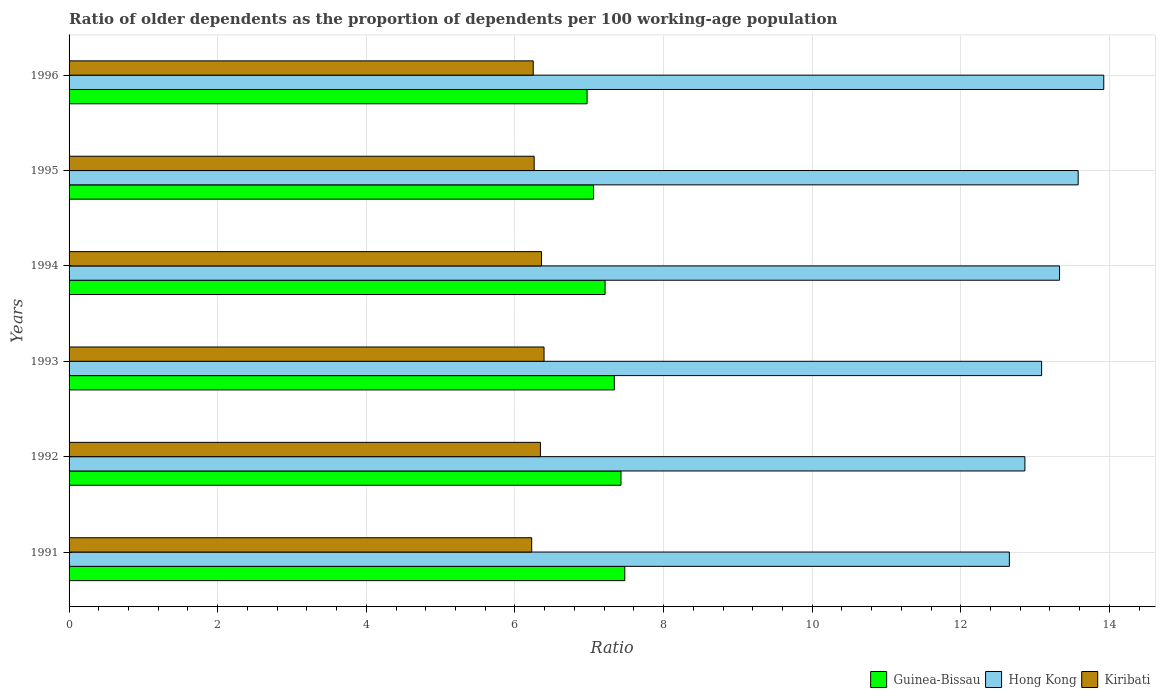How many different coloured bars are there?
Provide a succinct answer. 3. Are the number of bars per tick equal to the number of legend labels?
Keep it short and to the point. Yes. How many bars are there on the 5th tick from the bottom?
Give a very brief answer. 3. In how many cases, is the number of bars for a given year not equal to the number of legend labels?
Your answer should be compact. 0. What is the age dependency ratio(old) in Hong Kong in 1991?
Your response must be concise. 12.65. Across all years, what is the maximum age dependency ratio(old) in Guinea-Bissau?
Offer a very short reply. 7.48. Across all years, what is the minimum age dependency ratio(old) in Guinea-Bissau?
Give a very brief answer. 6.97. In which year was the age dependency ratio(old) in Kiribati maximum?
Your answer should be compact. 1993. What is the total age dependency ratio(old) in Hong Kong in the graph?
Provide a short and direct response. 79.44. What is the difference between the age dependency ratio(old) in Guinea-Bissau in 1994 and that in 1995?
Keep it short and to the point. 0.15. What is the difference between the age dependency ratio(old) in Guinea-Bissau in 1994 and the age dependency ratio(old) in Hong Kong in 1991?
Your answer should be very brief. -5.44. What is the average age dependency ratio(old) in Guinea-Bissau per year?
Provide a succinct answer. 7.25. In the year 1996, what is the difference between the age dependency ratio(old) in Kiribati and age dependency ratio(old) in Hong Kong?
Your answer should be compact. -7.68. What is the ratio of the age dependency ratio(old) in Hong Kong in 1993 to that in 1995?
Your answer should be very brief. 0.96. Is the difference between the age dependency ratio(old) in Kiribati in 1991 and 1994 greater than the difference between the age dependency ratio(old) in Hong Kong in 1991 and 1994?
Make the answer very short. Yes. What is the difference between the highest and the second highest age dependency ratio(old) in Guinea-Bissau?
Your answer should be compact. 0.05. What is the difference between the highest and the lowest age dependency ratio(old) in Hong Kong?
Give a very brief answer. 1.27. In how many years, is the age dependency ratio(old) in Guinea-Bissau greater than the average age dependency ratio(old) in Guinea-Bissau taken over all years?
Provide a succinct answer. 3. What does the 3rd bar from the top in 1996 represents?
Offer a very short reply. Guinea-Bissau. What does the 3rd bar from the bottom in 1993 represents?
Provide a short and direct response. Kiribati. How many bars are there?
Give a very brief answer. 18. Are all the bars in the graph horizontal?
Offer a very short reply. Yes. How many years are there in the graph?
Your answer should be very brief. 6. Are the values on the major ticks of X-axis written in scientific E-notation?
Your answer should be very brief. No. Does the graph contain grids?
Keep it short and to the point. Yes. Where does the legend appear in the graph?
Offer a terse response. Bottom right. How many legend labels are there?
Offer a terse response. 3. What is the title of the graph?
Make the answer very short. Ratio of older dependents as the proportion of dependents per 100 working-age population. Does "Latin America(developing only)" appear as one of the legend labels in the graph?
Your response must be concise. No. What is the label or title of the X-axis?
Your response must be concise. Ratio. What is the Ratio of Guinea-Bissau in 1991?
Make the answer very short. 7.48. What is the Ratio in Hong Kong in 1991?
Ensure brevity in your answer.  12.65. What is the Ratio in Kiribati in 1991?
Provide a short and direct response. 6.23. What is the Ratio in Guinea-Bissau in 1992?
Your answer should be very brief. 7.43. What is the Ratio in Hong Kong in 1992?
Make the answer very short. 12.86. What is the Ratio in Kiribati in 1992?
Your answer should be compact. 6.34. What is the Ratio of Guinea-Bissau in 1993?
Offer a very short reply. 7.34. What is the Ratio in Hong Kong in 1993?
Give a very brief answer. 13.09. What is the Ratio of Kiribati in 1993?
Your answer should be very brief. 6.39. What is the Ratio of Guinea-Bissau in 1994?
Give a very brief answer. 7.21. What is the Ratio in Hong Kong in 1994?
Make the answer very short. 13.33. What is the Ratio of Kiribati in 1994?
Your answer should be compact. 6.36. What is the Ratio in Guinea-Bissau in 1995?
Give a very brief answer. 7.06. What is the Ratio of Hong Kong in 1995?
Offer a very short reply. 13.58. What is the Ratio in Kiribati in 1995?
Your answer should be compact. 6.26. What is the Ratio of Guinea-Bissau in 1996?
Your answer should be compact. 6.97. What is the Ratio in Hong Kong in 1996?
Offer a very short reply. 13.92. What is the Ratio of Kiribati in 1996?
Your answer should be very brief. 6.25. Across all years, what is the maximum Ratio of Guinea-Bissau?
Your answer should be compact. 7.48. Across all years, what is the maximum Ratio in Hong Kong?
Your answer should be very brief. 13.92. Across all years, what is the maximum Ratio in Kiribati?
Your response must be concise. 6.39. Across all years, what is the minimum Ratio in Guinea-Bissau?
Your answer should be very brief. 6.97. Across all years, what is the minimum Ratio in Hong Kong?
Your response must be concise. 12.65. Across all years, what is the minimum Ratio of Kiribati?
Offer a terse response. 6.23. What is the total Ratio of Guinea-Bissau in the graph?
Provide a succinct answer. 43.49. What is the total Ratio of Hong Kong in the graph?
Give a very brief answer. 79.44. What is the total Ratio in Kiribati in the graph?
Your response must be concise. 37.82. What is the difference between the Ratio of Guinea-Bissau in 1991 and that in 1992?
Ensure brevity in your answer.  0.05. What is the difference between the Ratio of Hong Kong in 1991 and that in 1992?
Your response must be concise. -0.21. What is the difference between the Ratio in Kiribati in 1991 and that in 1992?
Your response must be concise. -0.12. What is the difference between the Ratio of Guinea-Bissau in 1991 and that in 1993?
Make the answer very short. 0.14. What is the difference between the Ratio of Hong Kong in 1991 and that in 1993?
Make the answer very short. -0.43. What is the difference between the Ratio in Kiribati in 1991 and that in 1993?
Your answer should be very brief. -0.17. What is the difference between the Ratio of Guinea-Bissau in 1991 and that in 1994?
Offer a very short reply. 0.27. What is the difference between the Ratio in Hong Kong in 1991 and that in 1994?
Ensure brevity in your answer.  -0.68. What is the difference between the Ratio in Kiribati in 1991 and that in 1994?
Make the answer very short. -0.13. What is the difference between the Ratio of Guinea-Bissau in 1991 and that in 1995?
Your response must be concise. 0.42. What is the difference between the Ratio of Hong Kong in 1991 and that in 1995?
Offer a very short reply. -0.93. What is the difference between the Ratio of Kiribati in 1991 and that in 1995?
Offer a very short reply. -0.03. What is the difference between the Ratio in Guinea-Bissau in 1991 and that in 1996?
Offer a very short reply. 0.51. What is the difference between the Ratio of Hong Kong in 1991 and that in 1996?
Ensure brevity in your answer.  -1.27. What is the difference between the Ratio in Kiribati in 1991 and that in 1996?
Keep it short and to the point. -0.02. What is the difference between the Ratio of Guinea-Bissau in 1992 and that in 1993?
Provide a short and direct response. 0.09. What is the difference between the Ratio in Hong Kong in 1992 and that in 1993?
Ensure brevity in your answer.  -0.23. What is the difference between the Ratio in Kiribati in 1992 and that in 1993?
Your answer should be compact. -0.05. What is the difference between the Ratio of Guinea-Bissau in 1992 and that in 1994?
Provide a short and direct response. 0.21. What is the difference between the Ratio of Hong Kong in 1992 and that in 1994?
Your response must be concise. -0.47. What is the difference between the Ratio of Kiribati in 1992 and that in 1994?
Your response must be concise. -0.01. What is the difference between the Ratio of Guinea-Bissau in 1992 and that in 1995?
Make the answer very short. 0.37. What is the difference between the Ratio in Hong Kong in 1992 and that in 1995?
Make the answer very short. -0.72. What is the difference between the Ratio in Kiribati in 1992 and that in 1995?
Make the answer very short. 0.08. What is the difference between the Ratio in Guinea-Bissau in 1992 and that in 1996?
Your response must be concise. 0.46. What is the difference between the Ratio in Hong Kong in 1992 and that in 1996?
Your answer should be compact. -1.06. What is the difference between the Ratio in Kiribati in 1992 and that in 1996?
Offer a very short reply. 0.1. What is the difference between the Ratio of Guinea-Bissau in 1993 and that in 1994?
Your response must be concise. 0.12. What is the difference between the Ratio in Hong Kong in 1993 and that in 1994?
Your answer should be very brief. -0.24. What is the difference between the Ratio in Kiribati in 1993 and that in 1994?
Keep it short and to the point. 0.03. What is the difference between the Ratio in Guinea-Bissau in 1993 and that in 1995?
Your answer should be very brief. 0.28. What is the difference between the Ratio in Hong Kong in 1993 and that in 1995?
Your response must be concise. -0.49. What is the difference between the Ratio of Kiribati in 1993 and that in 1995?
Provide a short and direct response. 0.13. What is the difference between the Ratio of Guinea-Bissau in 1993 and that in 1996?
Provide a short and direct response. 0.37. What is the difference between the Ratio in Hong Kong in 1993 and that in 1996?
Your answer should be very brief. -0.84. What is the difference between the Ratio of Kiribati in 1993 and that in 1996?
Make the answer very short. 0.15. What is the difference between the Ratio in Guinea-Bissau in 1994 and that in 1995?
Provide a short and direct response. 0.15. What is the difference between the Ratio in Hong Kong in 1994 and that in 1995?
Your answer should be very brief. -0.25. What is the difference between the Ratio in Kiribati in 1994 and that in 1995?
Your answer should be very brief. 0.1. What is the difference between the Ratio in Guinea-Bissau in 1994 and that in 1996?
Your answer should be very brief. 0.24. What is the difference between the Ratio of Hong Kong in 1994 and that in 1996?
Keep it short and to the point. -0.59. What is the difference between the Ratio of Kiribati in 1994 and that in 1996?
Your answer should be very brief. 0.11. What is the difference between the Ratio in Guinea-Bissau in 1995 and that in 1996?
Ensure brevity in your answer.  0.09. What is the difference between the Ratio in Hong Kong in 1995 and that in 1996?
Your answer should be compact. -0.34. What is the difference between the Ratio in Kiribati in 1995 and that in 1996?
Your response must be concise. 0.01. What is the difference between the Ratio in Guinea-Bissau in 1991 and the Ratio in Hong Kong in 1992?
Your answer should be very brief. -5.38. What is the difference between the Ratio of Guinea-Bissau in 1991 and the Ratio of Kiribati in 1992?
Your answer should be very brief. 1.14. What is the difference between the Ratio in Hong Kong in 1991 and the Ratio in Kiribati in 1992?
Provide a succinct answer. 6.31. What is the difference between the Ratio in Guinea-Bissau in 1991 and the Ratio in Hong Kong in 1993?
Your response must be concise. -5.61. What is the difference between the Ratio in Guinea-Bissau in 1991 and the Ratio in Kiribati in 1993?
Your response must be concise. 1.09. What is the difference between the Ratio of Hong Kong in 1991 and the Ratio of Kiribati in 1993?
Make the answer very short. 6.26. What is the difference between the Ratio of Guinea-Bissau in 1991 and the Ratio of Hong Kong in 1994?
Offer a terse response. -5.85. What is the difference between the Ratio of Guinea-Bissau in 1991 and the Ratio of Kiribati in 1994?
Your answer should be very brief. 1.12. What is the difference between the Ratio in Hong Kong in 1991 and the Ratio in Kiribati in 1994?
Your answer should be very brief. 6.3. What is the difference between the Ratio in Guinea-Bissau in 1991 and the Ratio in Hong Kong in 1995?
Provide a short and direct response. -6.1. What is the difference between the Ratio in Guinea-Bissau in 1991 and the Ratio in Kiribati in 1995?
Your response must be concise. 1.22. What is the difference between the Ratio of Hong Kong in 1991 and the Ratio of Kiribati in 1995?
Keep it short and to the point. 6.39. What is the difference between the Ratio in Guinea-Bissau in 1991 and the Ratio in Hong Kong in 1996?
Your response must be concise. -6.45. What is the difference between the Ratio in Guinea-Bissau in 1991 and the Ratio in Kiribati in 1996?
Provide a short and direct response. 1.23. What is the difference between the Ratio of Hong Kong in 1991 and the Ratio of Kiribati in 1996?
Provide a short and direct response. 6.41. What is the difference between the Ratio in Guinea-Bissau in 1992 and the Ratio in Hong Kong in 1993?
Ensure brevity in your answer.  -5.66. What is the difference between the Ratio in Guinea-Bissau in 1992 and the Ratio in Kiribati in 1993?
Your answer should be very brief. 1.04. What is the difference between the Ratio in Hong Kong in 1992 and the Ratio in Kiribati in 1993?
Offer a very short reply. 6.47. What is the difference between the Ratio in Guinea-Bissau in 1992 and the Ratio in Hong Kong in 1994?
Provide a short and direct response. -5.9. What is the difference between the Ratio of Guinea-Bissau in 1992 and the Ratio of Kiribati in 1994?
Give a very brief answer. 1.07. What is the difference between the Ratio in Hong Kong in 1992 and the Ratio in Kiribati in 1994?
Give a very brief answer. 6.5. What is the difference between the Ratio in Guinea-Bissau in 1992 and the Ratio in Hong Kong in 1995?
Your answer should be compact. -6.15. What is the difference between the Ratio of Guinea-Bissau in 1992 and the Ratio of Kiribati in 1995?
Offer a very short reply. 1.17. What is the difference between the Ratio in Hong Kong in 1992 and the Ratio in Kiribati in 1995?
Provide a succinct answer. 6.6. What is the difference between the Ratio in Guinea-Bissau in 1992 and the Ratio in Hong Kong in 1996?
Provide a short and direct response. -6.5. What is the difference between the Ratio in Guinea-Bissau in 1992 and the Ratio in Kiribati in 1996?
Give a very brief answer. 1.18. What is the difference between the Ratio of Hong Kong in 1992 and the Ratio of Kiribati in 1996?
Your response must be concise. 6.62. What is the difference between the Ratio of Guinea-Bissau in 1993 and the Ratio of Hong Kong in 1994?
Your response must be concise. -5.99. What is the difference between the Ratio in Guinea-Bissau in 1993 and the Ratio in Kiribati in 1994?
Your answer should be compact. 0.98. What is the difference between the Ratio in Hong Kong in 1993 and the Ratio in Kiribati in 1994?
Provide a short and direct response. 6.73. What is the difference between the Ratio in Guinea-Bissau in 1993 and the Ratio in Hong Kong in 1995?
Offer a terse response. -6.24. What is the difference between the Ratio of Guinea-Bissau in 1993 and the Ratio of Kiribati in 1995?
Your response must be concise. 1.08. What is the difference between the Ratio in Hong Kong in 1993 and the Ratio in Kiribati in 1995?
Your answer should be very brief. 6.83. What is the difference between the Ratio of Guinea-Bissau in 1993 and the Ratio of Hong Kong in 1996?
Ensure brevity in your answer.  -6.59. What is the difference between the Ratio of Guinea-Bissau in 1993 and the Ratio of Kiribati in 1996?
Provide a succinct answer. 1.09. What is the difference between the Ratio of Hong Kong in 1993 and the Ratio of Kiribati in 1996?
Your response must be concise. 6.84. What is the difference between the Ratio in Guinea-Bissau in 1994 and the Ratio in Hong Kong in 1995?
Offer a terse response. -6.37. What is the difference between the Ratio of Guinea-Bissau in 1994 and the Ratio of Kiribati in 1995?
Keep it short and to the point. 0.95. What is the difference between the Ratio of Hong Kong in 1994 and the Ratio of Kiribati in 1995?
Your answer should be compact. 7.07. What is the difference between the Ratio in Guinea-Bissau in 1994 and the Ratio in Hong Kong in 1996?
Your response must be concise. -6.71. What is the difference between the Ratio in Guinea-Bissau in 1994 and the Ratio in Kiribati in 1996?
Offer a terse response. 0.97. What is the difference between the Ratio of Hong Kong in 1994 and the Ratio of Kiribati in 1996?
Make the answer very short. 7.08. What is the difference between the Ratio of Guinea-Bissau in 1995 and the Ratio of Hong Kong in 1996?
Offer a very short reply. -6.87. What is the difference between the Ratio in Guinea-Bissau in 1995 and the Ratio in Kiribati in 1996?
Keep it short and to the point. 0.81. What is the difference between the Ratio of Hong Kong in 1995 and the Ratio of Kiribati in 1996?
Provide a succinct answer. 7.33. What is the average Ratio in Guinea-Bissau per year?
Offer a terse response. 7.25. What is the average Ratio in Hong Kong per year?
Your answer should be very brief. 13.24. What is the average Ratio in Kiribati per year?
Make the answer very short. 6.3. In the year 1991, what is the difference between the Ratio in Guinea-Bissau and Ratio in Hong Kong?
Your response must be concise. -5.18. In the year 1991, what is the difference between the Ratio of Guinea-Bissau and Ratio of Kiribati?
Provide a short and direct response. 1.25. In the year 1991, what is the difference between the Ratio of Hong Kong and Ratio of Kiribati?
Provide a short and direct response. 6.43. In the year 1992, what is the difference between the Ratio of Guinea-Bissau and Ratio of Hong Kong?
Offer a very short reply. -5.43. In the year 1992, what is the difference between the Ratio in Guinea-Bissau and Ratio in Kiribati?
Provide a short and direct response. 1.08. In the year 1992, what is the difference between the Ratio in Hong Kong and Ratio in Kiribati?
Offer a very short reply. 6.52. In the year 1993, what is the difference between the Ratio of Guinea-Bissau and Ratio of Hong Kong?
Keep it short and to the point. -5.75. In the year 1993, what is the difference between the Ratio of Guinea-Bissau and Ratio of Kiribati?
Your answer should be very brief. 0.95. In the year 1993, what is the difference between the Ratio of Hong Kong and Ratio of Kiribati?
Ensure brevity in your answer.  6.7. In the year 1994, what is the difference between the Ratio in Guinea-Bissau and Ratio in Hong Kong?
Ensure brevity in your answer.  -6.12. In the year 1994, what is the difference between the Ratio of Guinea-Bissau and Ratio of Kiribati?
Provide a short and direct response. 0.86. In the year 1994, what is the difference between the Ratio in Hong Kong and Ratio in Kiribati?
Your answer should be very brief. 6.97. In the year 1995, what is the difference between the Ratio of Guinea-Bissau and Ratio of Hong Kong?
Your answer should be compact. -6.52. In the year 1995, what is the difference between the Ratio of Guinea-Bissau and Ratio of Kiribati?
Provide a succinct answer. 0.8. In the year 1995, what is the difference between the Ratio of Hong Kong and Ratio of Kiribati?
Offer a very short reply. 7.32. In the year 1996, what is the difference between the Ratio in Guinea-Bissau and Ratio in Hong Kong?
Provide a succinct answer. -6.95. In the year 1996, what is the difference between the Ratio of Guinea-Bissau and Ratio of Kiribati?
Your answer should be compact. 0.72. In the year 1996, what is the difference between the Ratio in Hong Kong and Ratio in Kiribati?
Keep it short and to the point. 7.68. What is the ratio of the Ratio of Guinea-Bissau in 1991 to that in 1992?
Make the answer very short. 1.01. What is the ratio of the Ratio in Hong Kong in 1991 to that in 1992?
Offer a terse response. 0.98. What is the ratio of the Ratio in Kiribati in 1991 to that in 1992?
Keep it short and to the point. 0.98. What is the ratio of the Ratio in Guinea-Bissau in 1991 to that in 1993?
Your response must be concise. 1.02. What is the ratio of the Ratio of Hong Kong in 1991 to that in 1993?
Provide a succinct answer. 0.97. What is the ratio of the Ratio in Kiribati in 1991 to that in 1993?
Provide a short and direct response. 0.97. What is the ratio of the Ratio of Guinea-Bissau in 1991 to that in 1994?
Ensure brevity in your answer.  1.04. What is the ratio of the Ratio in Hong Kong in 1991 to that in 1994?
Offer a very short reply. 0.95. What is the ratio of the Ratio in Kiribati in 1991 to that in 1994?
Ensure brevity in your answer.  0.98. What is the ratio of the Ratio in Guinea-Bissau in 1991 to that in 1995?
Provide a short and direct response. 1.06. What is the ratio of the Ratio of Hong Kong in 1991 to that in 1995?
Your response must be concise. 0.93. What is the ratio of the Ratio of Kiribati in 1991 to that in 1995?
Offer a very short reply. 0.99. What is the ratio of the Ratio in Guinea-Bissau in 1991 to that in 1996?
Your response must be concise. 1.07. What is the ratio of the Ratio in Hong Kong in 1991 to that in 1996?
Provide a short and direct response. 0.91. What is the ratio of the Ratio of Kiribati in 1991 to that in 1996?
Provide a short and direct response. 1. What is the ratio of the Ratio in Guinea-Bissau in 1992 to that in 1993?
Give a very brief answer. 1.01. What is the ratio of the Ratio of Hong Kong in 1992 to that in 1993?
Make the answer very short. 0.98. What is the ratio of the Ratio in Kiribati in 1992 to that in 1993?
Keep it short and to the point. 0.99. What is the ratio of the Ratio of Guinea-Bissau in 1992 to that in 1994?
Offer a very short reply. 1.03. What is the ratio of the Ratio of Hong Kong in 1992 to that in 1994?
Make the answer very short. 0.96. What is the ratio of the Ratio of Guinea-Bissau in 1992 to that in 1995?
Offer a very short reply. 1.05. What is the ratio of the Ratio in Hong Kong in 1992 to that in 1995?
Keep it short and to the point. 0.95. What is the ratio of the Ratio in Kiribati in 1992 to that in 1995?
Your answer should be very brief. 1.01. What is the ratio of the Ratio of Guinea-Bissau in 1992 to that in 1996?
Ensure brevity in your answer.  1.07. What is the ratio of the Ratio in Hong Kong in 1992 to that in 1996?
Offer a very short reply. 0.92. What is the ratio of the Ratio in Kiribati in 1992 to that in 1996?
Give a very brief answer. 1.02. What is the ratio of the Ratio of Guinea-Bissau in 1993 to that in 1994?
Offer a very short reply. 1.02. What is the ratio of the Ratio in Hong Kong in 1993 to that in 1994?
Keep it short and to the point. 0.98. What is the ratio of the Ratio in Kiribati in 1993 to that in 1994?
Keep it short and to the point. 1.01. What is the ratio of the Ratio in Guinea-Bissau in 1993 to that in 1995?
Your answer should be very brief. 1.04. What is the ratio of the Ratio in Hong Kong in 1993 to that in 1995?
Offer a terse response. 0.96. What is the ratio of the Ratio in Kiribati in 1993 to that in 1995?
Offer a very short reply. 1.02. What is the ratio of the Ratio in Guinea-Bissau in 1993 to that in 1996?
Your answer should be very brief. 1.05. What is the ratio of the Ratio in Hong Kong in 1993 to that in 1996?
Make the answer very short. 0.94. What is the ratio of the Ratio in Kiribati in 1993 to that in 1996?
Ensure brevity in your answer.  1.02. What is the ratio of the Ratio of Guinea-Bissau in 1994 to that in 1995?
Keep it short and to the point. 1.02. What is the ratio of the Ratio in Hong Kong in 1994 to that in 1995?
Offer a terse response. 0.98. What is the ratio of the Ratio in Kiribati in 1994 to that in 1995?
Ensure brevity in your answer.  1.02. What is the ratio of the Ratio of Guinea-Bissau in 1994 to that in 1996?
Your response must be concise. 1.03. What is the ratio of the Ratio in Hong Kong in 1994 to that in 1996?
Your response must be concise. 0.96. What is the ratio of the Ratio in Kiribati in 1994 to that in 1996?
Ensure brevity in your answer.  1.02. What is the ratio of the Ratio of Guinea-Bissau in 1995 to that in 1996?
Offer a very short reply. 1.01. What is the ratio of the Ratio in Hong Kong in 1995 to that in 1996?
Your answer should be compact. 0.98. What is the ratio of the Ratio in Kiribati in 1995 to that in 1996?
Provide a succinct answer. 1. What is the difference between the highest and the second highest Ratio in Guinea-Bissau?
Your response must be concise. 0.05. What is the difference between the highest and the second highest Ratio in Hong Kong?
Your answer should be compact. 0.34. What is the difference between the highest and the second highest Ratio in Kiribati?
Keep it short and to the point. 0.03. What is the difference between the highest and the lowest Ratio in Guinea-Bissau?
Your response must be concise. 0.51. What is the difference between the highest and the lowest Ratio in Hong Kong?
Your response must be concise. 1.27. What is the difference between the highest and the lowest Ratio of Kiribati?
Make the answer very short. 0.17. 